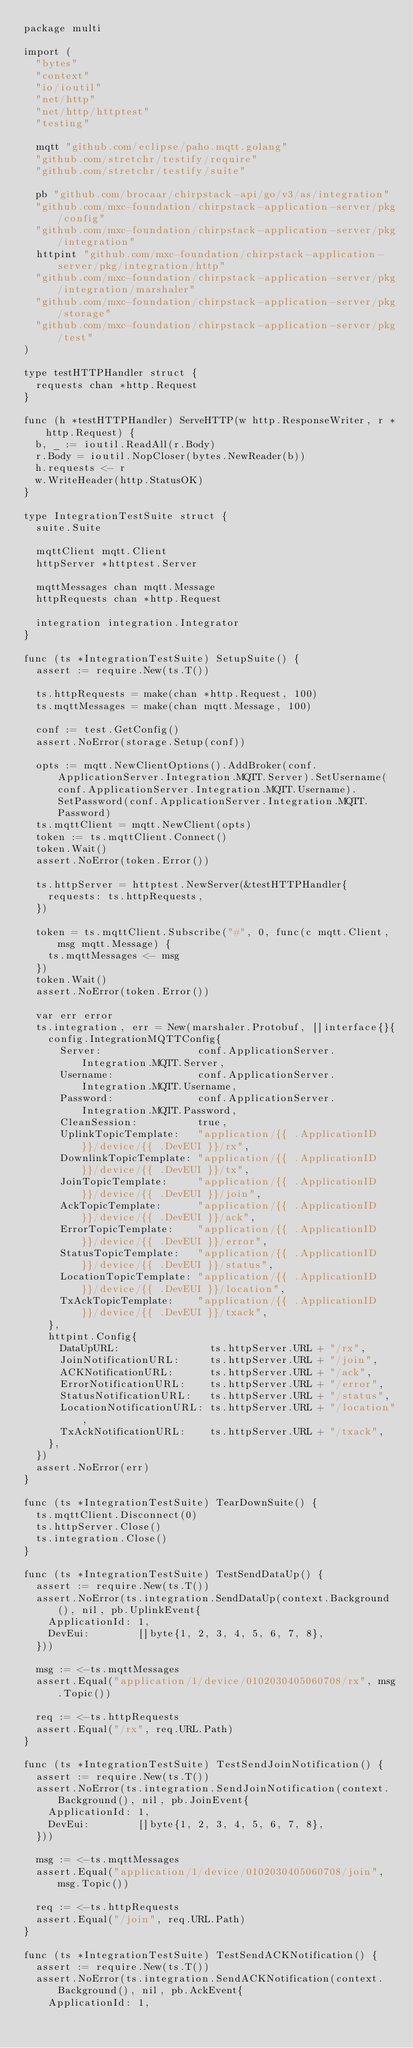Convert code to text. <code><loc_0><loc_0><loc_500><loc_500><_Go_>package multi

import (
	"bytes"
	"context"
	"io/ioutil"
	"net/http"
	"net/http/httptest"
	"testing"

	mqtt "github.com/eclipse/paho.mqtt.golang"
	"github.com/stretchr/testify/require"
	"github.com/stretchr/testify/suite"

	pb "github.com/brocaar/chirpstack-api/go/v3/as/integration"
	"github.com/mxc-foundation/chirpstack-application-server/pkg/config"
	"github.com/mxc-foundation/chirpstack-application-server/pkg/integration"
	httpint "github.com/mxc-foundation/chirpstack-application-server/pkg/integration/http"
	"github.com/mxc-foundation/chirpstack-application-server/pkg/integration/marshaler"
	"github.com/mxc-foundation/chirpstack-application-server/pkg/storage"
	"github.com/mxc-foundation/chirpstack-application-server/pkg/test"
)

type testHTTPHandler struct {
	requests chan *http.Request
}

func (h *testHTTPHandler) ServeHTTP(w http.ResponseWriter, r *http.Request) {
	b, _ := ioutil.ReadAll(r.Body)
	r.Body = ioutil.NopCloser(bytes.NewReader(b))
	h.requests <- r
	w.WriteHeader(http.StatusOK)
}

type IntegrationTestSuite struct {
	suite.Suite

	mqttClient mqtt.Client
	httpServer *httptest.Server

	mqttMessages chan mqtt.Message
	httpRequests chan *http.Request

	integration integration.Integrator
}

func (ts *IntegrationTestSuite) SetupSuite() {
	assert := require.New(ts.T())

	ts.httpRequests = make(chan *http.Request, 100)
	ts.mqttMessages = make(chan mqtt.Message, 100)

	conf := test.GetConfig()
	assert.NoError(storage.Setup(conf))

	opts := mqtt.NewClientOptions().AddBroker(conf.ApplicationServer.Integration.MQTT.Server).SetUsername(conf.ApplicationServer.Integration.MQTT.Username).SetPassword(conf.ApplicationServer.Integration.MQTT.Password)
	ts.mqttClient = mqtt.NewClient(opts)
	token := ts.mqttClient.Connect()
	token.Wait()
	assert.NoError(token.Error())

	ts.httpServer = httptest.NewServer(&testHTTPHandler{
		requests: ts.httpRequests,
	})

	token = ts.mqttClient.Subscribe("#", 0, func(c mqtt.Client, msg mqtt.Message) {
		ts.mqttMessages <- msg
	})
	token.Wait()
	assert.NoError(token.Error())

	var err error
	ts.integration, err = New(marshaler.Protobuf, []interface{}{
		config.IntegrationMQTTConfig{
			Server:                conf.ApplicationServer.Integration.MQTT.Server,
			Username:              conf.ApplicationServer.Integration.MQTT.Username,
			Password:              conf.ApplicationServer.Integration.MQTT.Password,
			CleanSession:          true,
			UplinkTopicTemplate:   "application/{{ .ApplicationID }}/device/{{ .DevEUI }}/rx",
			DownlinkTopicTemplate: "application/{{ .ApplicationID }}/device/{{ .DevEUI }}/tx",
			JoinTopicTemplate:     "application/{{ .ApplicationID }}/device/{{ .DevEUI }}/join",
			AckTopicTemplate:      "application/{{ .ApplicationID }}/device/{{ .DevEUI }}/ack",
			ErrorTopicTemplate:    "application/{{ .ApplicationID }}/device/{{ .DevEUI }}/error",
			StatusTopicTemplate:   "application/{{ .ApplicationID }}/device/{{ .DevEUI }}/status",
			LocationTopicTemplate: "application/{{ .ApplicationID }}/device/{{ .DevEUI }}/location",
			TxAckTopicTemplate:    "application/{{ .ApplicationID }}/device/{{ .DevEUI }}/txack",
		},
		httpint.Config{
			DataUpURL:               ts.httpServer.URL + "/rx",
			JoinNotificationURL:     ts.httpServer.URL + "/join",
			ACKNotificationURL:      ts.httpServer.URL + "/ack",
			ErrorNotificationURL:    ts.httpServer.URL + "/error",
			StatusNotificationURL:   ts.httpServer.URL + "/status",
			LocationNotificationURL: ts.httpServer.URL + "/location",
			TxAckNotificationURL:    ts.httpServer.URL + "/txack",
		},
	})
	assert.NoError(err)
}

func (ts *IntegrationTestSuite) TearDownSuite() {
	ts.mqttClient.Disconnect(0)
	ts.httpServer.Close()
	ts.integration.Close()
}

func (ts *IntegrationTestSuite) TestSendDataUp() {
	assert := require.New(ts.T())
	assert.NoError(ts.integration.SendDataUp(context.Background(), nil, pb.UplinkEvent{
		ApplicationId: 1,
		DevEui:        []byte{1, 2, 3, 4, 5, 6, 7, 8},
	}))

	msg := <-ts.mqttMessages
	assert.Equal("application/1/device/0102030405060708/rx", msg.Topic())

	req := <-ts.httpRequests
	assert.Equal("/rx", req.URL.Path)
}

func (ts *IntegrationTestSuite) TestSendJoinNotification() {
	assert := require.New(ts.T())
	assert.NoError(ts.integration.SendJoinNotification(context.Background(), nil, pb.JoinEvent{
		ApplicationId: 1,
		DevEui:        []byte{1, 2, 3, 4, 5, 6, 7, 8},
	}))

	msg := <-ts.mqttMessages
	assert.Equal("application/1/device/0102030405060708/join", msg.Topic())

	req := <-ts.httpRequests
	assert.Equal("/join", req.URL.Path)
}

func (ts *IntegrationTestSuite) TestSendACKNotification() {
	assert := require.New(ts.T())
	assert.NoError(ts.integration.SendACKNotification(context.Background(), nil, pb.AckEvent{
		ApplicationId: 1,</code> 